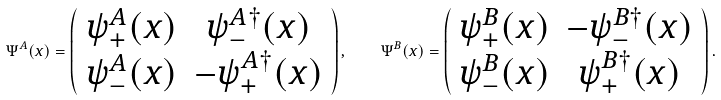Convert formula to latex. <formula><loc_0><loc_0><loc_500><loc_500>\Psi ^ { A } ( x ) = \left ( \begin{array} { c c } \psi ^ { A } _ { + } ( x ) & \psi ^ { A \dagger } _ { - } ( x ) \\ \psi ^ { A } _ { - } ( x ) & - \psi ^ { A \dagger } _ { + } ( x ) \end{array} \right ) , \quad \Psi ^ { B } ( x ) = \left ( \begin{array} { c c } \psi ^ { B } _ { + } ( x ) & - \psi ^ { B \dagger } _ { - } ( x ) \\ \psi ^ { B } _ { - } ( x ) & \psi ^ { B \dagger } _ { + } ( x ) \end{array} \right ) .</formula> 